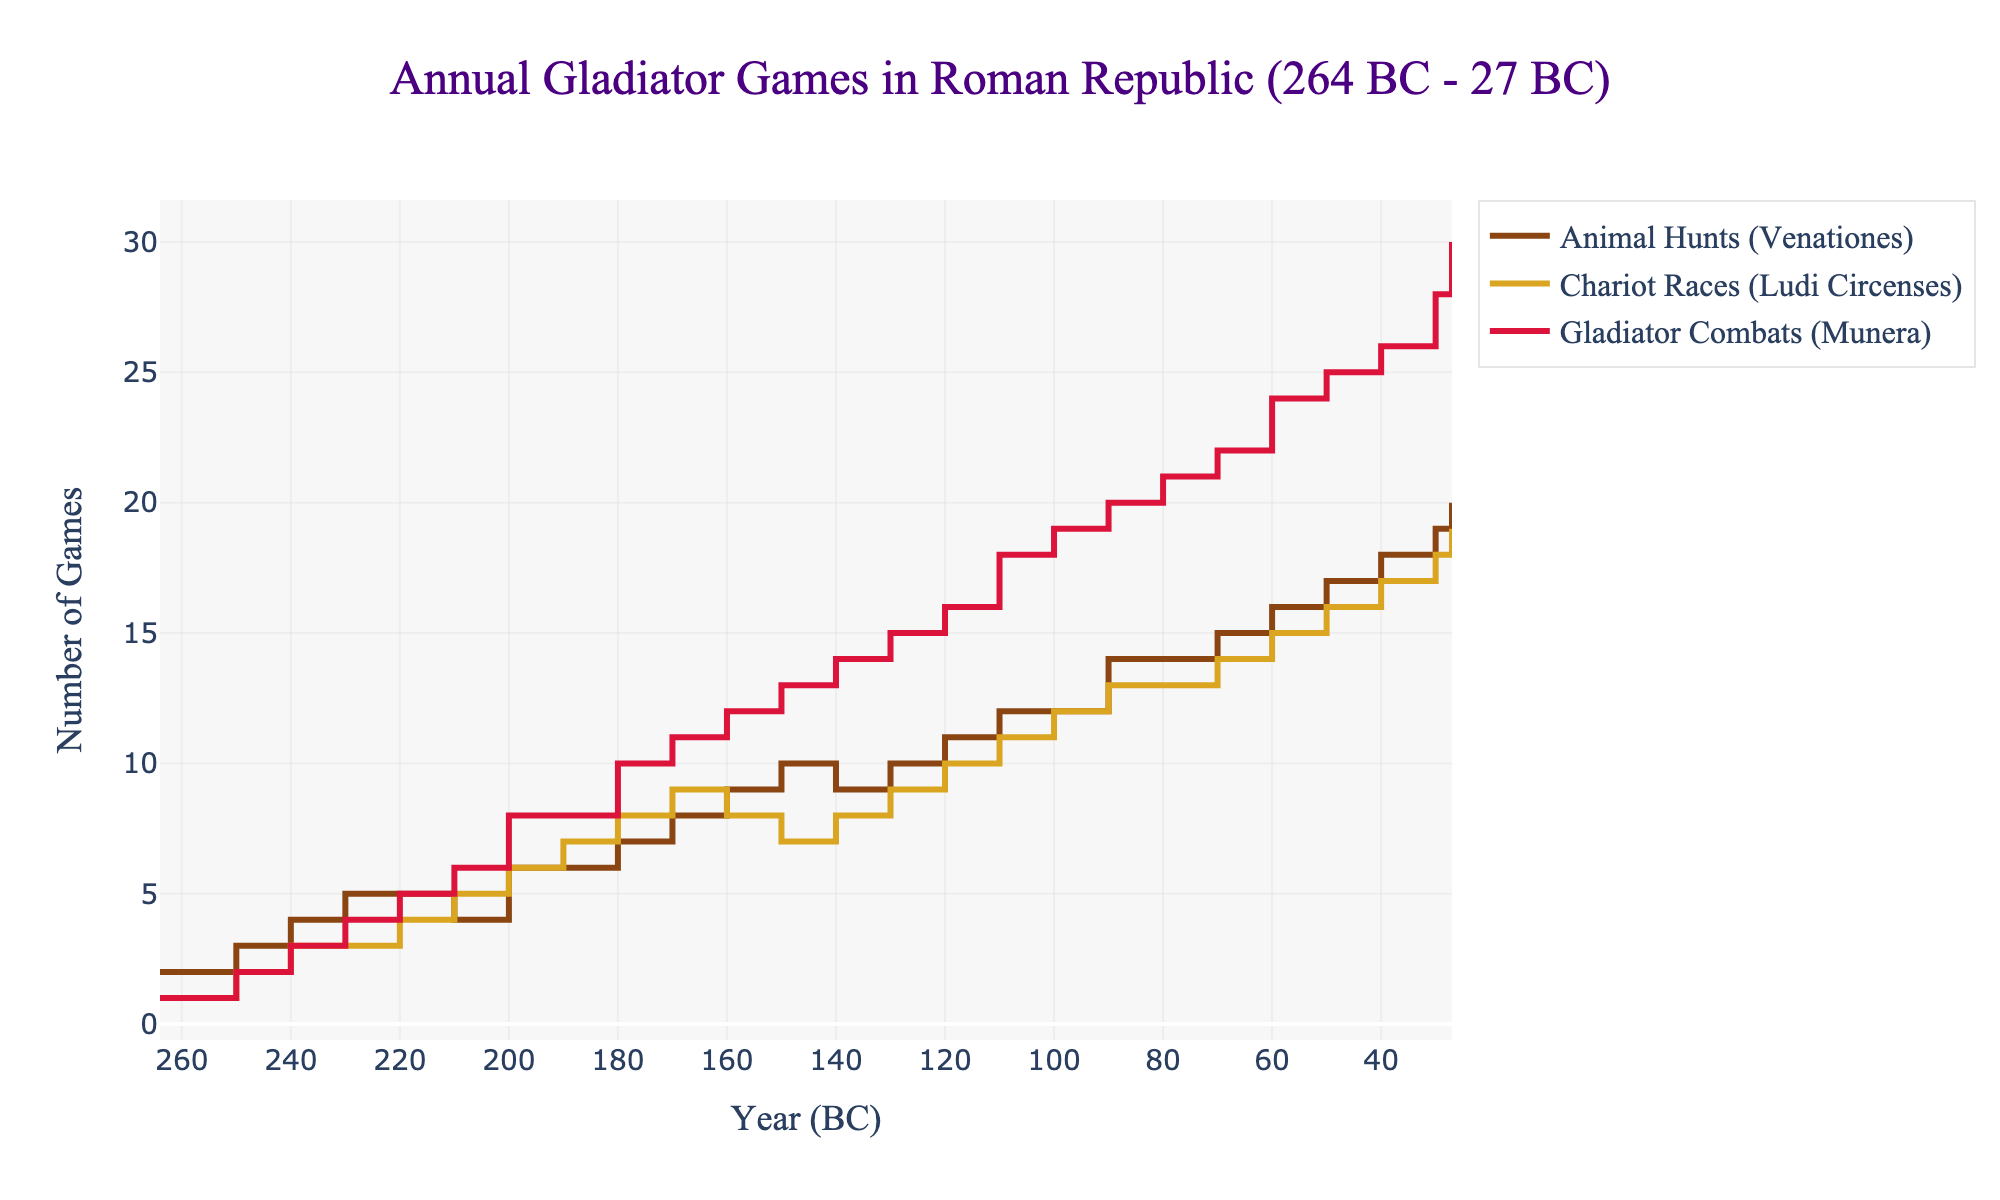What's the title of the plot? The title of the plot is usually located at the top and it provides a summary of the subject matter of the figure. The title helps in quickly understanding what the plot is about.
Answer: Annual Gladiator Games in Roman Republic (264 BC - 27 BC) What are the three types of games shown in the plot? The types of games are distinguished by different line colors and labels in the legend. By looking at the labels in the legend, we can identify them.
Answer: Animal Hunts (Venationes), Chariot Races (Ludi Circenses), Gladiator Combats (Munera) Which type of game had the highest number of events in the year 27 BC? Look at the end of the lines (year 27 BC on the x-axis). The highest y-value corresponds to the type of game with the most events.
Answer: Gladiator Combats (Munera) What is the total number of games held in 200 BC for all types? Add the values for each type of game for the year 200 BC. This involves finding the y-values for each line at the year 200 BC on the x-axis.
Answer: 20 How did the number of Chariot Races change between 240 BC and 210 BC? Find the y-values for Chariot Races at 240 BC and 210 BC, then compute the difference between these values to see the change.
Answer: Increased by 2 Which type of game showed the most consistent growth over the period? Assess the lines for their slopes over the entire period. The type with the most linear and steadily increasing line shows the most consistent growth.
Answer: Gladiator Combats (Munera) Between 170 BC and 150 BC, which type of game experienced a decrease in events? Look at the y-values for each type of game at 170 BC and 150 BC. Identify the type that shows a lower y-value at 150 BC compared to 170 BC.
Answer: Chariot Races (Ludi Circenses) What was the average number of Gladiator Combats held annually between 100 BC and 50 BC? Identify the y-values for Gladiator Combats at each decade from 100 BC to 50 BC, sum them up and then divide by the number of data points (6).
Answer: 20.5 In any given year, how can we determine which type of game was more popular based on the plot? For any specific year, the type of game with the highest y-value indicates it had more events, thus was more popular in terms of quantity.
Answer: The game with the highest y-value 